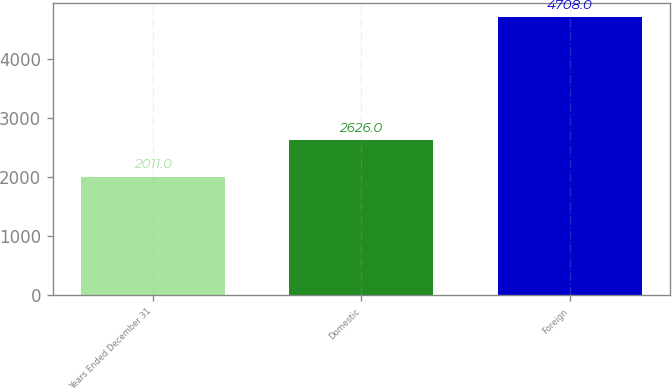Convert chart. <chart><loc_0><loc_0><loc_500><loc_500><bar_chart><fcel>Years Ended December 31<fcel>Domestic<fcel>Foreign<nl><fcel>2011<fcel>2626<fcel>4708<nl></chart> 